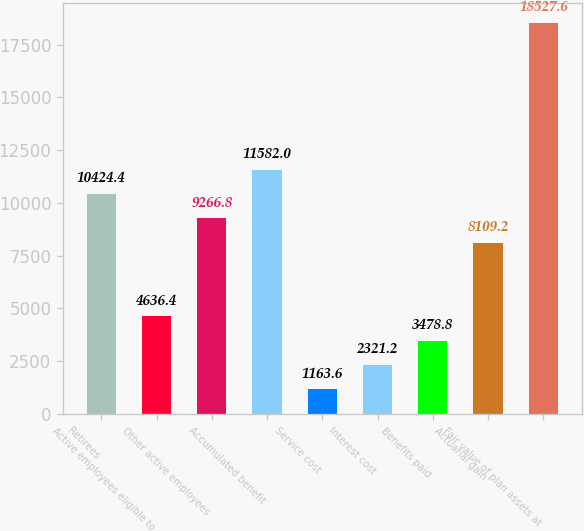<chart> <loc_0><loc_0><loc_500><loc_500><bar_chart><fcel>Retirees<fcel>Active employees eligible to<fcel>Other active employees<fcel>Accumulated benefit<fcel>Service cost<fcel>Interest cost<fcel>Benefits paid<fcel>Actuarial gain<fcel>Fair value of plan assets at<nl><fcel>10424.4<fcel>4636.4<fcel>9266.8<fcel>11582<fcel>1163.6<fcel>2321.2<fcel>3478.8<fcel>8109.2<fcel>18527.6<nl></chart> 